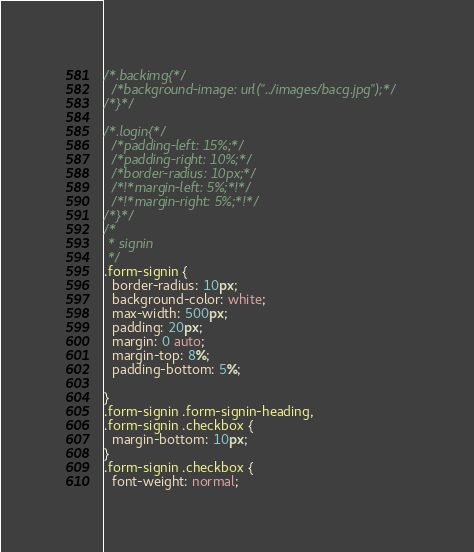Convert code to text. <code><loc_0><loc_0><loc_500><loc_500><_CSS_>
/*.backimg{*/
  /*background-image: url("../images/bacg.jpg");*/
/*}*/

/*.login{*/
  /*padding-left: 15%;*/
  /*padding-right: 10%;*/
  /*border-radius: 10px;*/
  /*!*margin-left: 5%;*!*/
  /*!*margin-right: 5%;*!*/
/*}*/
/*
 * signin
 */
.form-signin {
  border-radius: 10px;
  background-color: white;
  max-width: 500px;
  padding: 20px;
  margin: 0 auto;
  margin-top: 8%;
  padding-bottom: 5%;

}
.form-signin .form-signin-heading,
.form-signin .checkbox {
  margin-bottom: 10px;
}
.form-signin .checkbox {
  font-weight: normal;</code> 